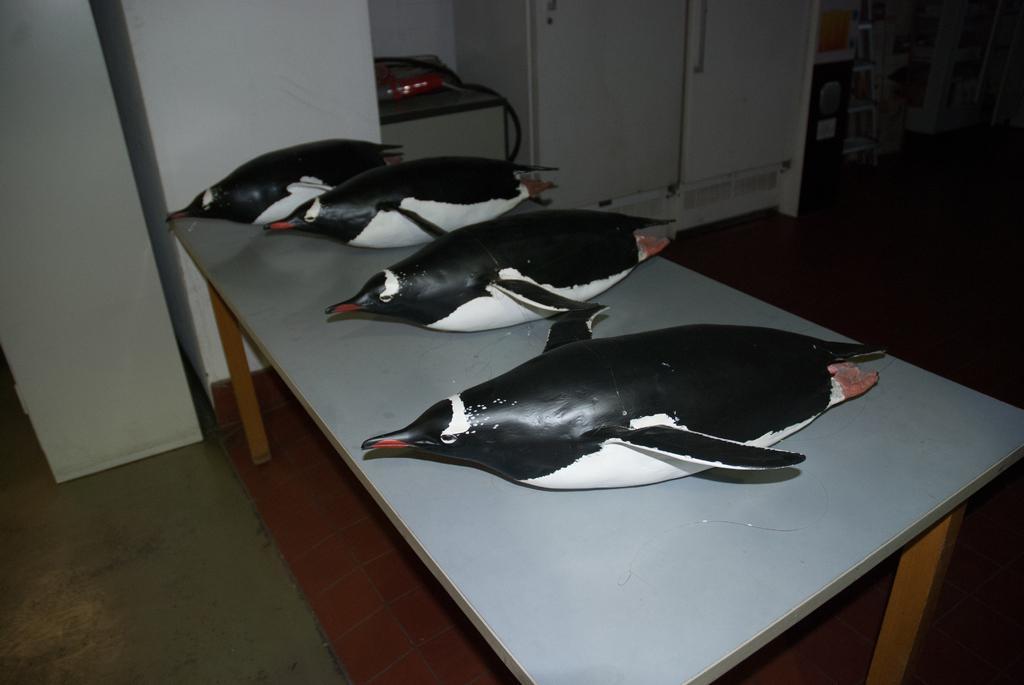In one or two sentences, can you explain what this image depicts? In the picture we can see a table, on it we can see four penguin sculpture are placed behind the table and we can see a part of the wall and beside it, we can see a cupboard which is white in color and beside it we can see some things. 